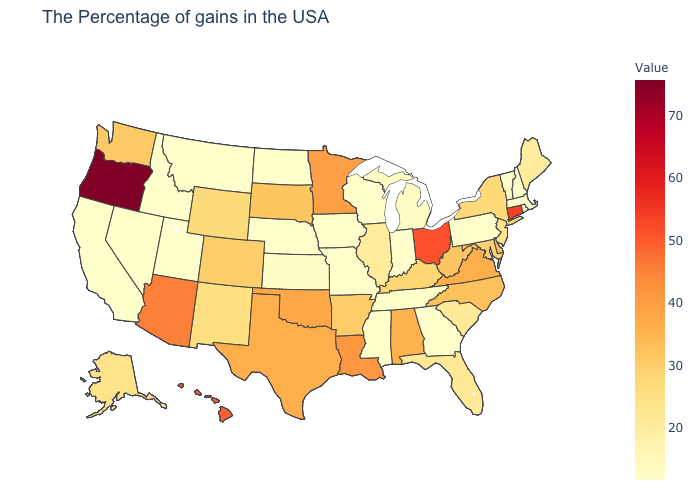Among the states that border Florida , does Alabama have the lowest value?
Give a very brief answer. No. Is the legend a continuous bar?
Short answer required. Yes. Among the states that border Georgia , which have the lowest value?
Quick response, please. Tennessee. Does New Mexico have the lowest value in the West?
Give a very brief answer. No. Among the states that border Colorado , which have the highest value?
Write a very short answer. Arizona. Does California have the lowest value in the West?
Concise answer only. Yes. Does Oregon have the lowest value in the USA?
Quick response, please. No. Does Tennessee have the lowest value in the South?
Keep it brief. Yes. Among the states that border Minnesota , does South Dakota have the highest value?
Answer briefly. Yes. Does Nebraska have the lowest value in the USA?
Answer briefly. Yes. 